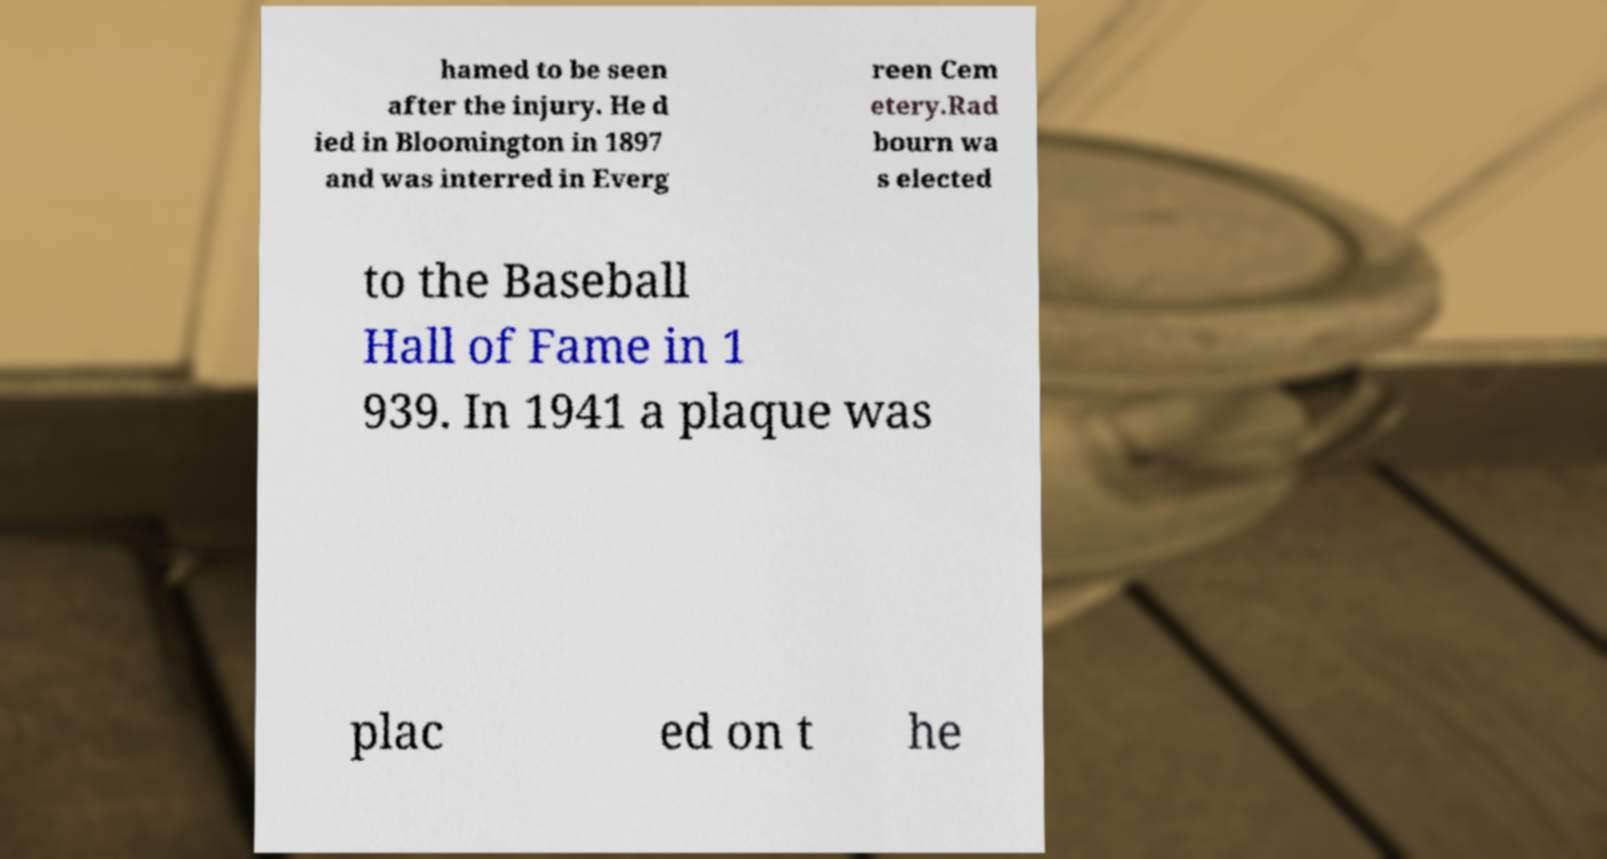Can you read and provide the text displayed in the image?This photo seems to have some interesting text. Can you extract and type it out for me? hamed to be seen after the injury. He d ied in Bloomington in 1897 and was interred in Everg reen Cem etery.Rad bourn wa s elected to the Baseball Hall of Fame in 1 939. In 1941 a plaque was plac ed on t he 